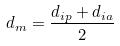Convert formula to latex. <formula><loc_0><loc_0><loc_500><loc_500>d _ { m } = \frac { d _ { i p } + d _ { i a } } { 2 }</formula> 